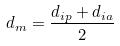Convert formula to latex. <formula><loc_0><loc_0><loc_500><loc_500>d _ { m } = \frac { d _ { i p } + d _ { i a } } { 2 }</formula> 